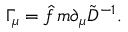<formula> <loc_0><loc_0><loc_500><loc_500>\Gamma _ { \mu } = \hat { f } \, m \partial _ { \mu } \tilde { D } ^ { - 1 } .</formula> 